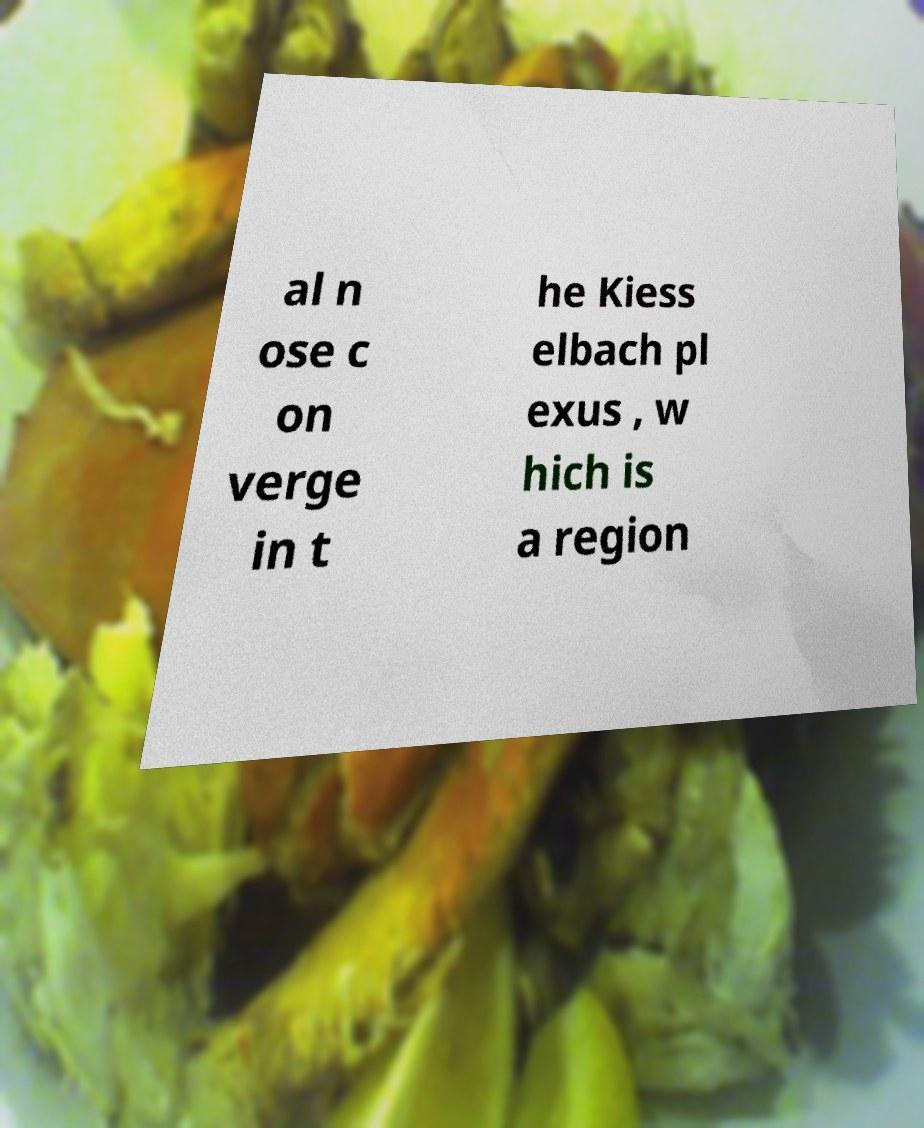There's text embedded in this image that I need extracted. Can you transcribe it verbatim? al n ose c on verge in t he Kiess elbach pl exus , w hich is a region 